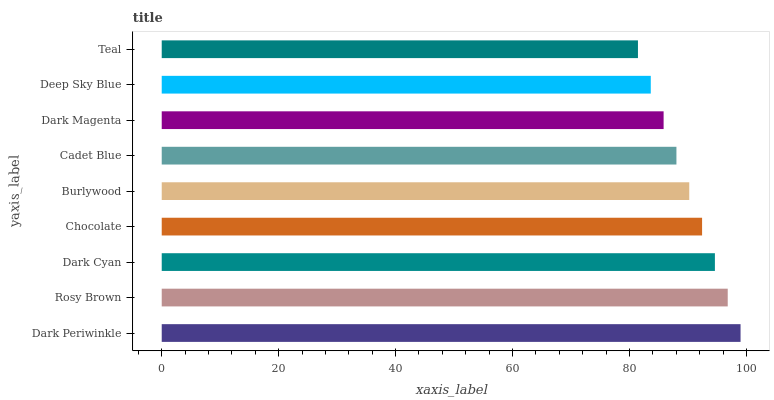Is Teal the minimum?
Answer yes or no. Yes. Is Dark Periwinkle the maximum?
Answer yes or no. Yes. Is Rosy Brown the minimum?
Answer yes or no. No. Is Rosy Brown the maximum?
Answer yes or no. No. Is Dark Periwinkle greater than Rosy Brown?
Answer yes or no. Yes. Is Rosy Brown less than Dark Periwinkle?
Answer yes or no. Yes. Is Rosy Brown greater than Dark Periwinkle?
Answer yes or no. No. Is Dark Periwinkle less than Rosy Brown?
Answer yes or no. No. Is Burlywood the high median?
Answer yes or no. Yes. Is Burlywood the low median?
Answer yes or no. Yes. Is Rosy Brown the high median?
Answer yes or no. No. Is Deep Sky Blue the low median?
Answer yes or no. No. 